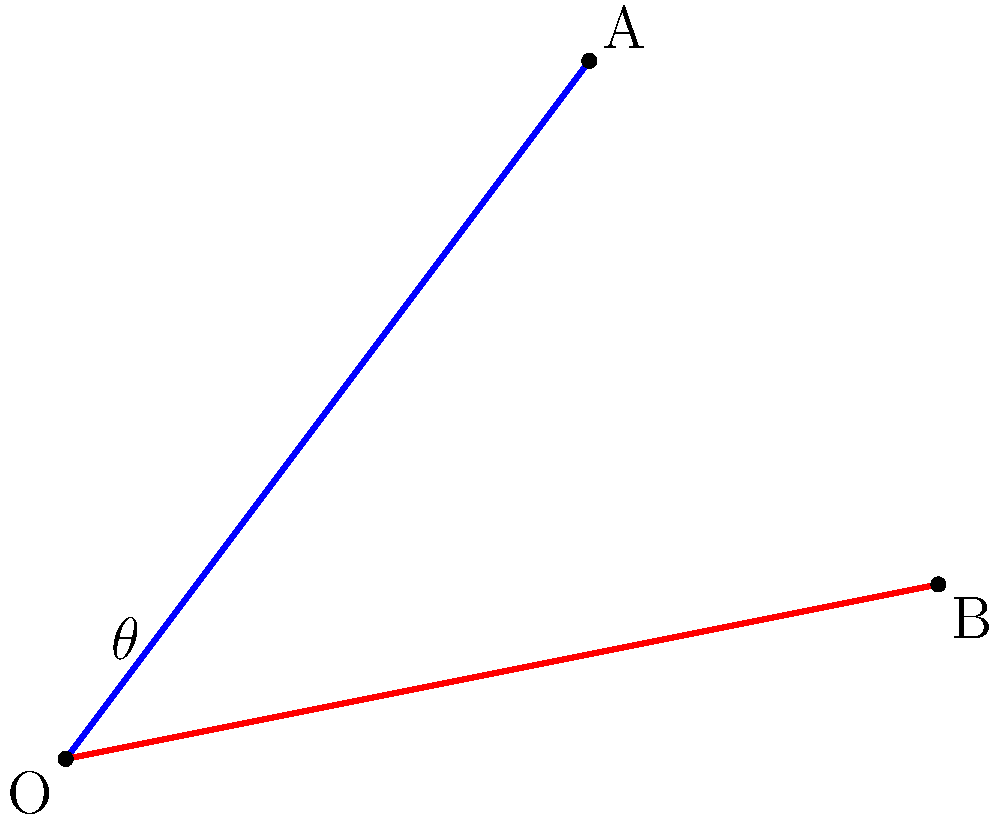As a calligraphy artist, you're designing an intricate book cover with intersecting strokes. Two calligraphic strokes are represented by vectors $\vec{OA}$ and $\vec{OB}$, where $O=(0,0)$, $A=(3,4)$, and $B=(5,1)$. Calculate the angle $\theta$ between these two strokes. To find the angle between two vectors, we can use the dot product formula:

$$\cos \theta = \frac{\vec{OA} \cdot \vec{OB}}{|\vec{OA}| |\vec{OB}|}$$

Step 1: Calculate the vectors $\vec{OA}$ and $\vec{OB}$
$\vec{OA} = (3,4)$
$\vec{OB} = (5,1)$

Step 2: Calculate the dot product $\vec{OA} \cdot \vec{OB}$
$\vec{OA} \cdot \vec{OB} = (3)(5) + (4)(1) = 15 + 4 = 19$

Step 3: Calculate the magnitudes of the vectors
$|\vec{OA}| = \sqrt{3^2 + 4^2} = \sqrt{9 + 16} = \sqrt{25} = 5$
$|\vec{OB}| = \sqrt{5^2 + 1^2} = \sqrt{25 + 1} = \sqrt{26}$

Step 4: Apply the dot product formula
$$\cos \theta = \frac{19}{5\sqrt{26}}$$

Step 5: Take the inverse cosine (arccos) of both sides
$$\theta = \arccos(\frac{19}{5\sqrt{26}})$$

Step 6: Calculate the result (in radians)
$\theta \approx 0.5095$ radians

Step 7: Convert to degrees
$\theta \approx 0.5095 \times \frac{180}{\pi} \approx 29.21°$
Answer: $29.21°$ 